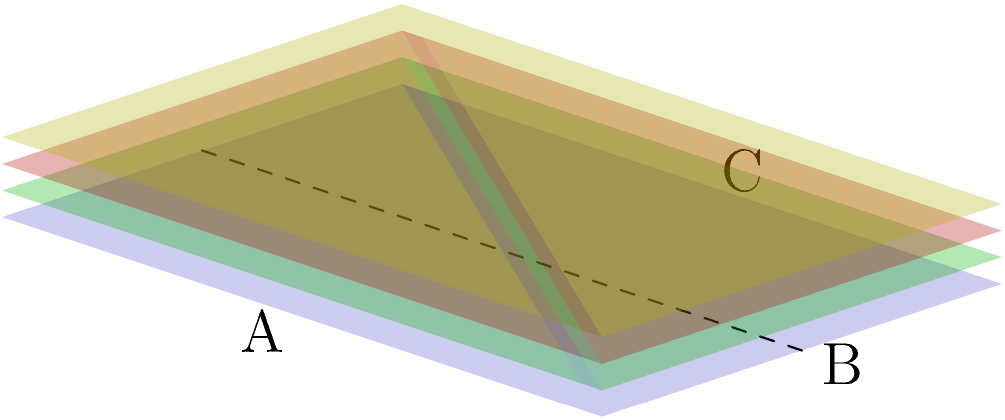As a politician considering balanced gun control measures, you're examining the structure of bullet-resistant vests. The image shows a simplified 3D model of a multi-layered vest. If a cross-section is taken along the dashed line, which of the following best represents the correct view?

1. A single solid rectangle
2. A rectangle with three distinct internal layers
3. A rectangle with a hollow interior
4. A rectangle with a single internal layer To answer this question, let's analyze the 3D model of the bullet-resistant vest step-by-step:

1. The vest is shown as a rectangular prism with multiple layers.

2. The dashed line indicates where the cross-section will be taken, running vertically through the center of the vest.

3. We can see that the vest consists of four distinct layers:
   a. The outer blue layer (representing the vest's outer shell)
   b. Three internal layers colored green, red, and yellow (representing different protective materials)

4. If we were to "cut" the vest along the dashed line and view it from the side, we would see:
   a. The outer edges of the vest forming a rectangle
   b. Three distinct internal layers within this rectangle

5. This cross-sectional view would reveal the layered structure of the vest, which is crucial for its bullet-resistant properties.

6. Understanding the construction of these vests is important for politicians considering gun control measures, as it provides insight into the protective equipment used by law enforcement and potentially civilians.

Based on this analysis, the correct representation of the cross-section would be a rectangle with three distinct internal layers.
Answer: A rectangle with three distinct internal layers 